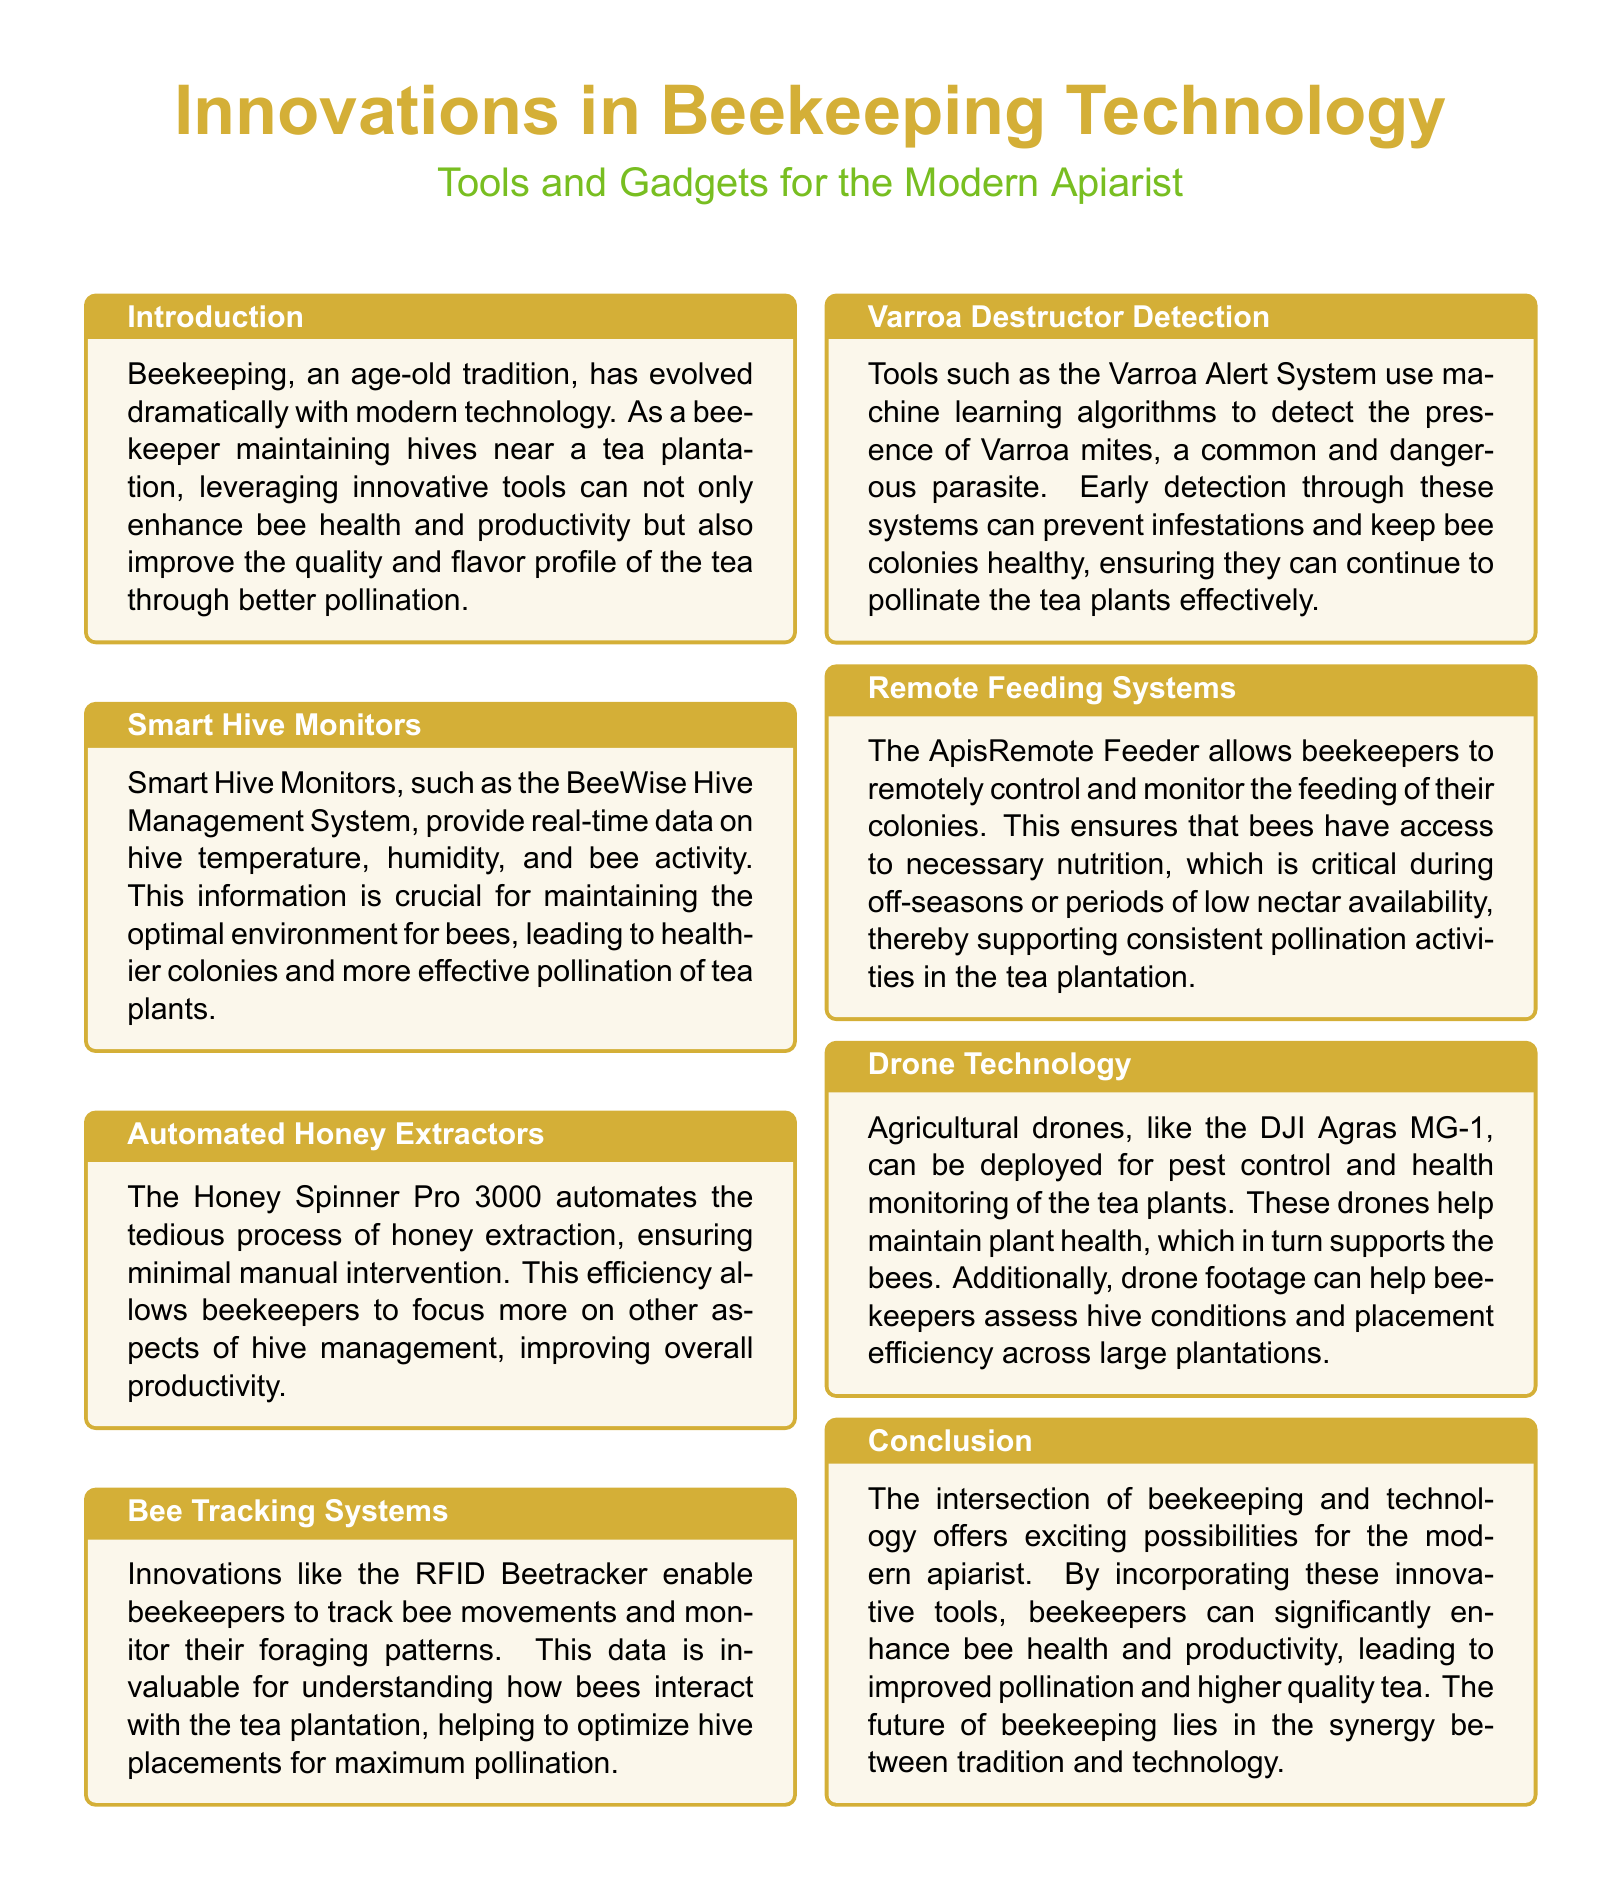What is the name of the smart hive monitor mentioned? The document mentions the "BeeWise Hive Management System" as a smart hive monitor.
Answer: BeeWise Hive Management System What does the Honey Spinner Pro 3000 automate? The Honey Spinner Pro 3000 automates the process of honey extraction.
Answer: Honey extraction What technology is used in the Varroa Alert System? The Varroa Alert System utilizes machine learning algorithms for detection.
Answer: Machine learning algorithms What can the RFID Beetracker monitor? The RFID Beetracker can monitor bee movements and foraging patterns.
Answer: Bee movements and foraging patterns What significant role do agricultural drones play besides pest control? They assist in health monitoring of tea plants, which benefits the bees.
Answer: Health monitoring How does the document describe the relationship between beekeeping and technology? It describes the relationship as offering exciting possibilities for modern apiarists.
Answer: Exciting possibilities What remote system is mentioned that allows feeding control? The ApisRemote Feeder is mentioned for remote feeding control.
Answer: ApisRemote Feeder What season does the remote feeding system specifically support? The remote feeding system supports off-seasons or periods of low nectar availability.
Answer: Off-seasons 